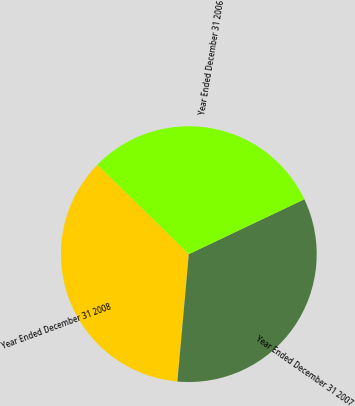Convert chart to OTSL. <chart><loc_0><loc_0><loc_500><loc_500><pie_chart><fcel>Year Ended December 31 2008<fcel>Year Ended December 31 2007<fcel>Year Ended December 31 2006<nl><fcel>35.91%<fcel>33.48%<fcel>30.61%<nl></chart> 